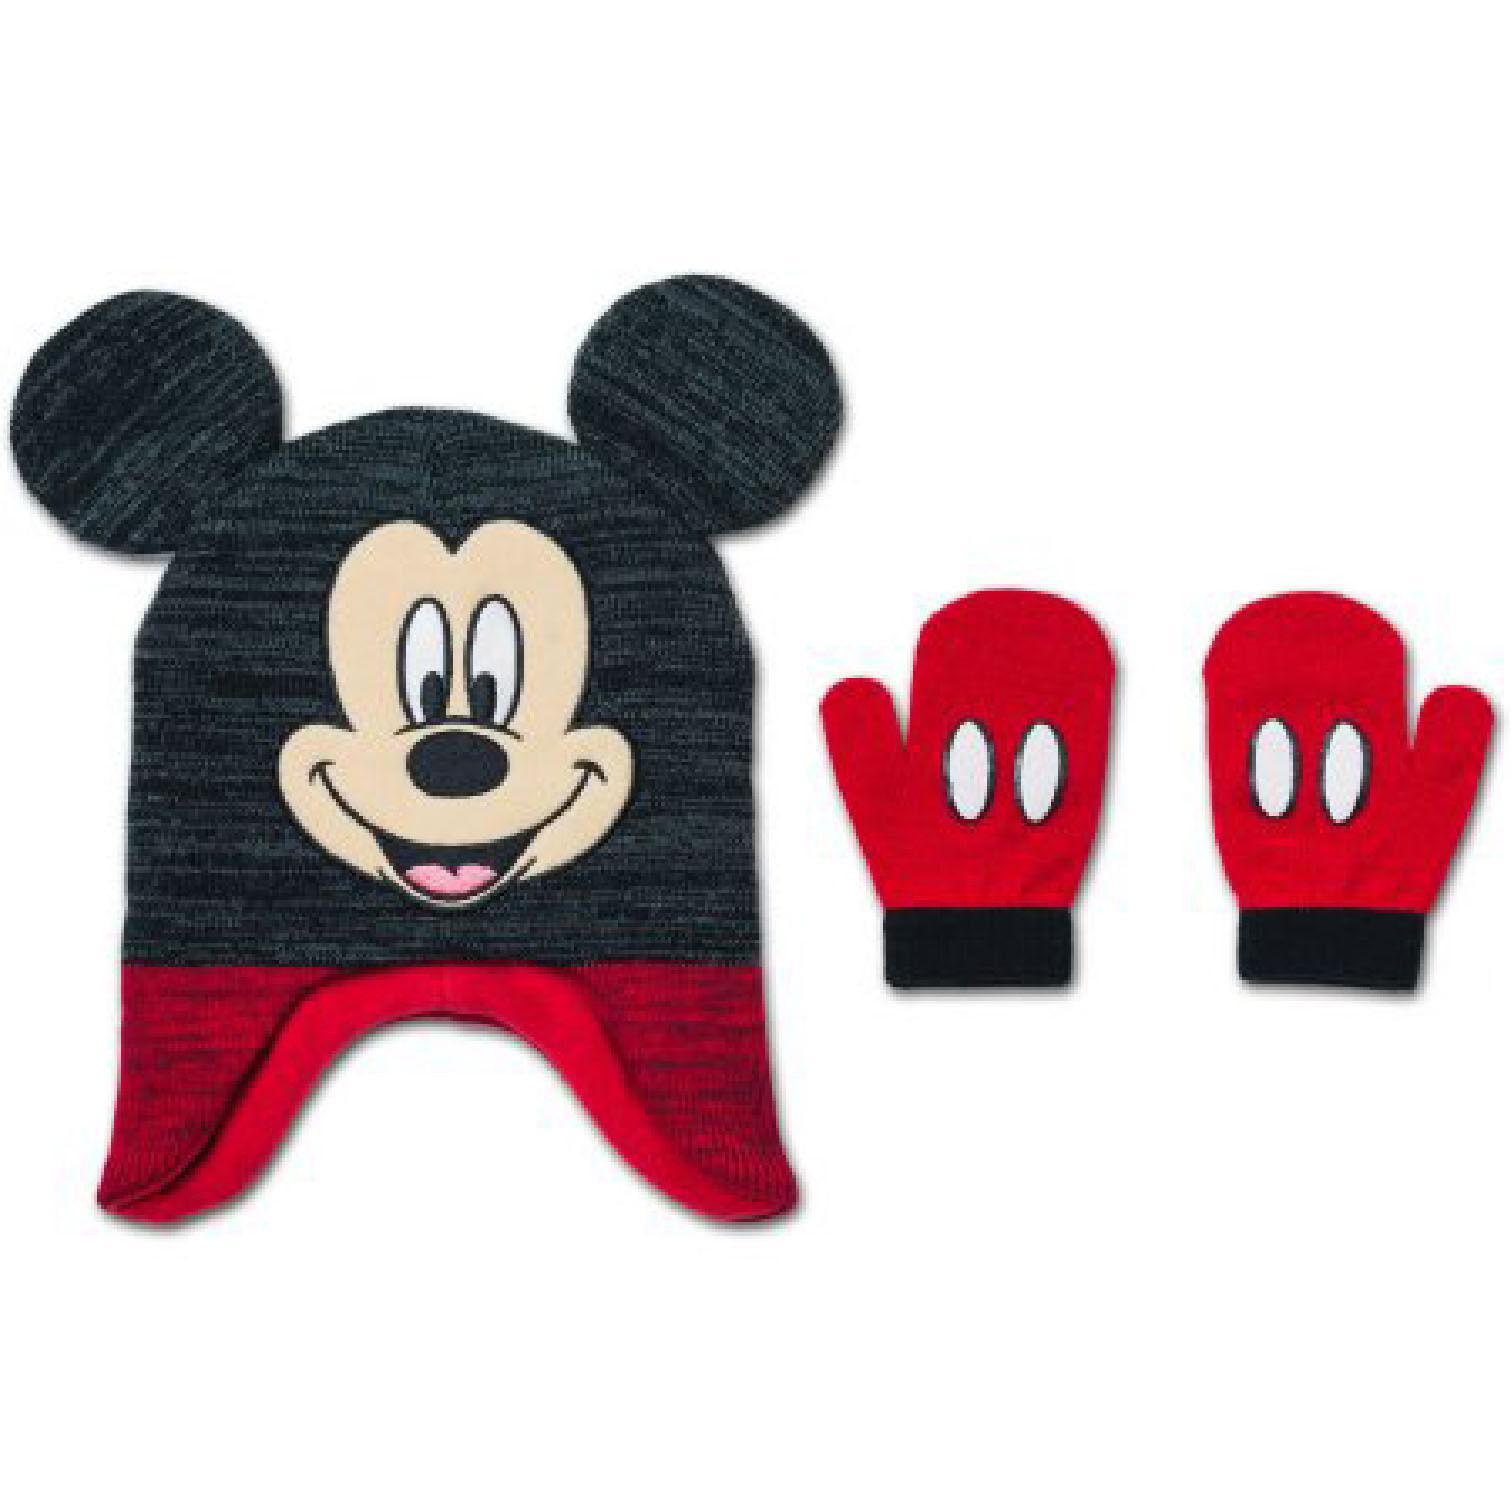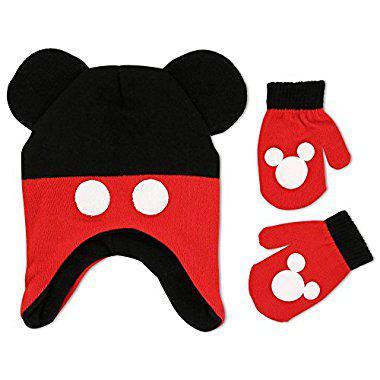The first image is the image on the left, the second image is the image on the right. Given the left and right images, does the statement "There is one black and red hat with black mouse ears and two white dots on it beside two red mittens with white Mickey Mouse logos and black cuffs in each image,." hold true? Answer yes or no. Yes. The first image is the image on the left, the second image is the image on the right. Evaluate the accuracy of this statement regarding the images: "One hat is black and red with two white button dots and one pair of red and black gloves has a white Mickey Mouse shape on each glove.". Is it true? Answer yes or no. Yes. 